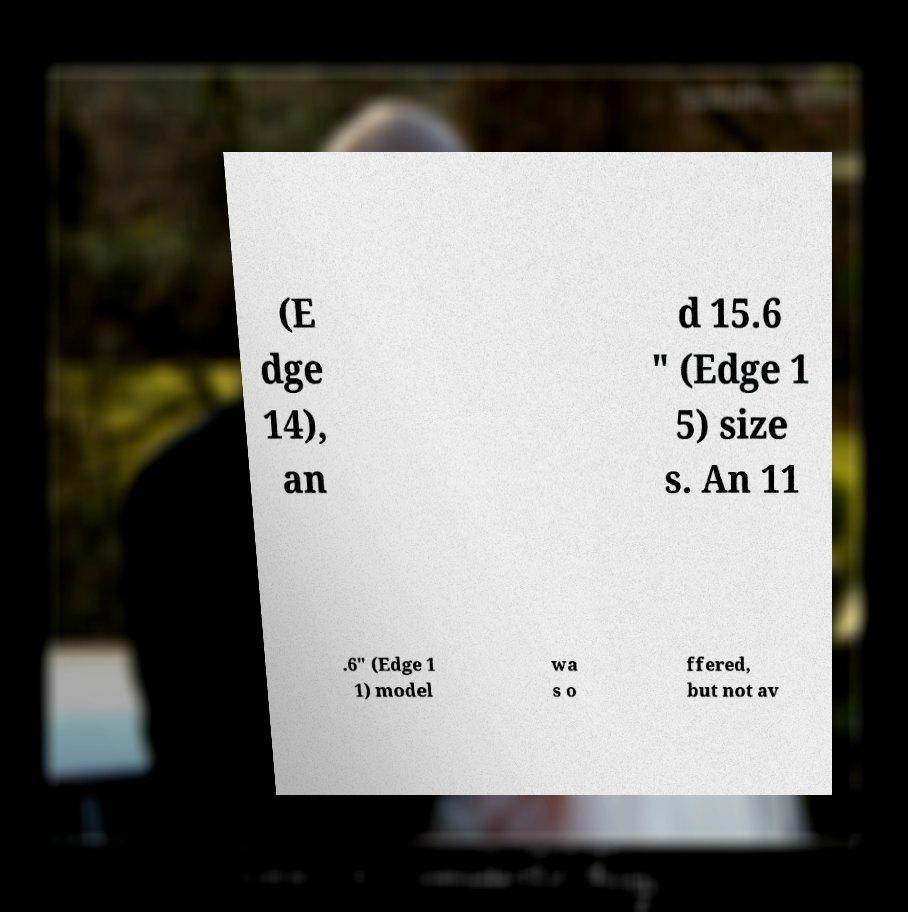Please read and relay the text visible in this image. What does it say? (E dge 14), an d 15.6 " (Edge 1 5) size s. An 11 .6" (Edge 1 1) model wa s o ffered, but not av 